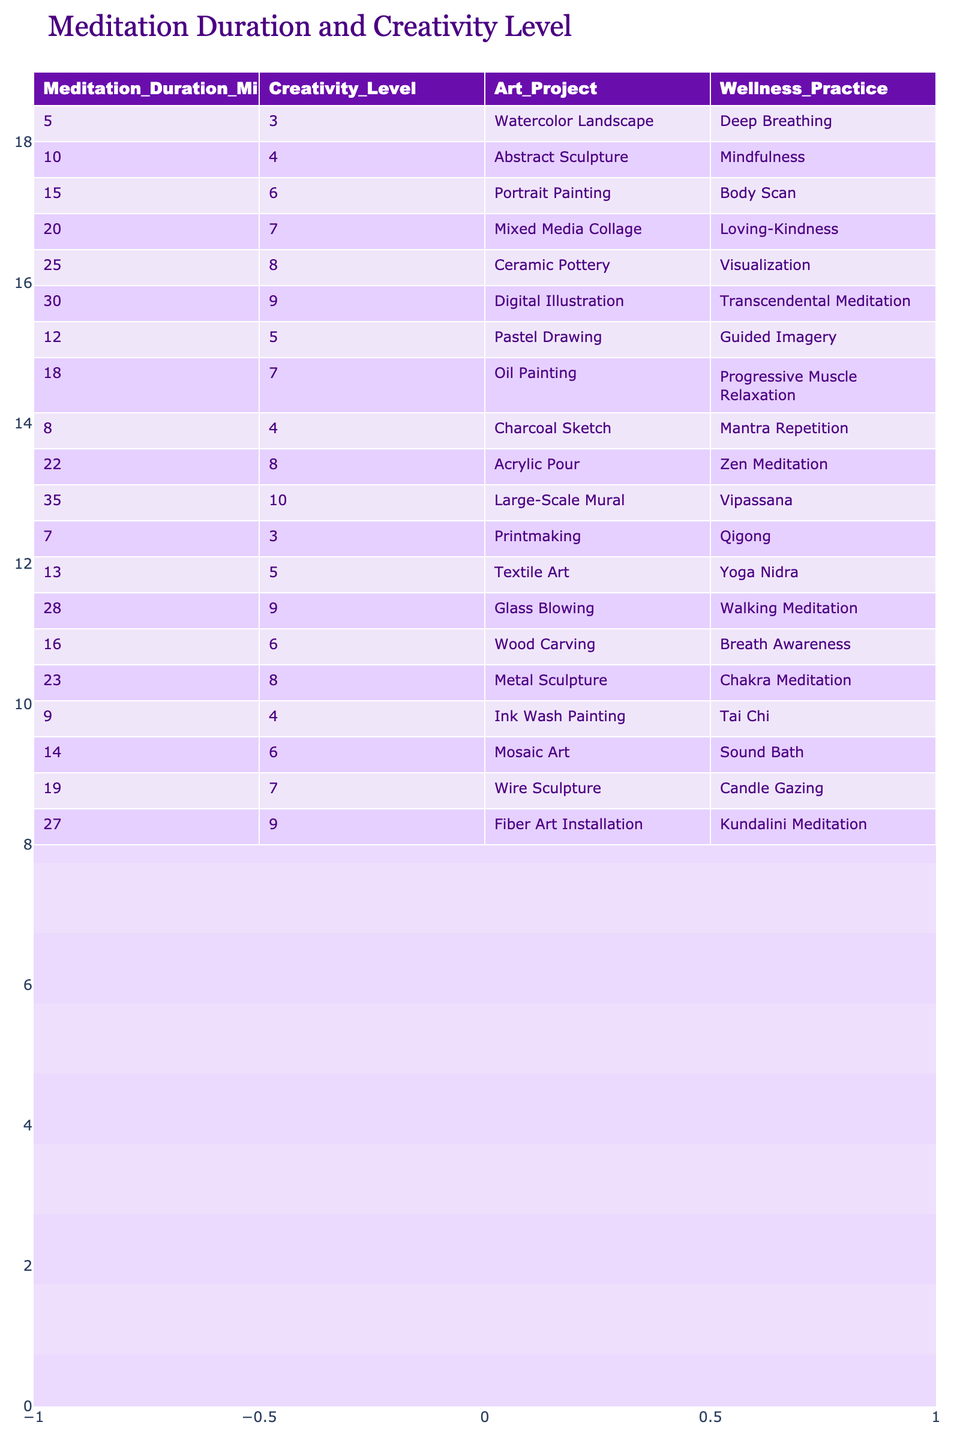What is the creativity level for a meditation duration of 20 minutes? The table shows that for a meditation duration of 20 minutes, the corresponding creativity level is 7.
Answer: 7 Which art project corresponds to the highest creativity level? Looking at the table, the highest creativity level is 10, which corresponds to the art project "Large-Scale Mural."
Answer: Large-Scale Mural What is the average creativity level for meditation durations of 10 minutes or less? The creativity levels corresponding to 5, 7, 8, and 10 minutes are 3, 4, 4, and 5 respectively. Their sum is 3 + 4 + 4 + 5 = 16, and there are 4 entries, so the average is 16/4 = 4.
Answer: 4 True or False: A meditation duration of 35 minutes results in a creativity level of 9. The table indicates that a meditation duration of 35 minutes corresponds to a creativity level of 10, not 9, so the statement is false.
Answer: False What is the difference in creativity levels between 15 minutes and 25 minutes of meditation? For 15 minutes, the creativity level is 6, and for 25 minutes, it is 8. The difference is 8 - 6 = 2.
Answer: 2 How does the creativity level change as meditation duration increases from 5 to 30 minutes, and what is the overall trend? Looking at the table, creativity levels increase from 3 at 5 minutes to 9 at 30 minutes. The values are increasing, showing a positive trend in creativity levels with longer meditation durations.
Answer: Positive trend Which art project has the second highest creativity level? The second highest creativity level in the table is 9, which corresponds to two art projects: "Digital Illustration" and "Fiber Art Installation."
Answer: Digital Illustration and Fiber Art Installation What is the total number of minutes among the meditation durations listed in the table that correspond to creativity levels above 7? The durations with creativity levels above 7 are 25 (8), 30 (9), 35 (10), 28 (9), and 27 (9). Adding these gives 25 + 30 + 35 + 28 + 27 = 175.
Answer: 175 What wellness practice is used for the project "Oil Painting"? The table shows that the wellness practice for the project "Oil Painting" is "Progressive Muscle Relaxation."
Answer: Progressive Muscle Relaxation Which meditation duration had the lowest creativity level and what was it? The table indicates that the lowest creativity level is 3, which corresponds to a meditation duration of 5 minutes.
Answer: 5 minutes, 3 